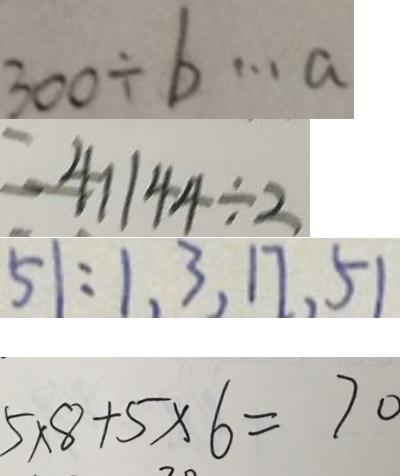<formula> <loc_0><loc_0><loc_500><loc_500>3 0 0 \div b \cdots a 
 = 4 1 1 4 4 \div 2 
 5 1 : 1 , 3 , 1 7 , 5 1 
 5 \times 8 + 5 \times 6 = 7 0</formula> 